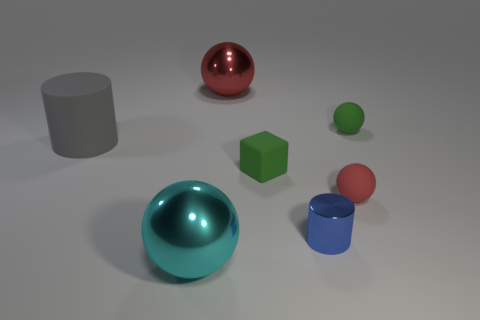What is the material of the small ball that is the same color as the matte block?
Provide a short and direct response. Rubber. There is a shiny object left of the big metallic object behind the cyan metal thing that is in front of the big gray cylinder; what size is it?
Give a very brief answer. Large. The ball that is both behind the gray cylinder and left of the green block is what color?
Give a very brief answer. Red. What number of tiny gray spheres are there?
Ensure brevity in your answer.  0. Does the gray object have the same material as the green block?
Provide a short and direct response. Yes. Do the cylinder that is left of the large red ball and the green matte thing that is right of the green rubber cube have the same size?
Give a very brief answer. No. Are there fewer rubber balls than small yellow rubber spheres?
Provide a short and direct response. No. What number of rubber things are brown spheres or spheres?
Provide a short and direct response. 2. There is a large ball behind the large cyan object; is there a green cube in front of it?
Offer a terse response. Yes. Do the red sphere in front of the rubber cube and the large red thing have the same material?
Make the answer very short. No. 